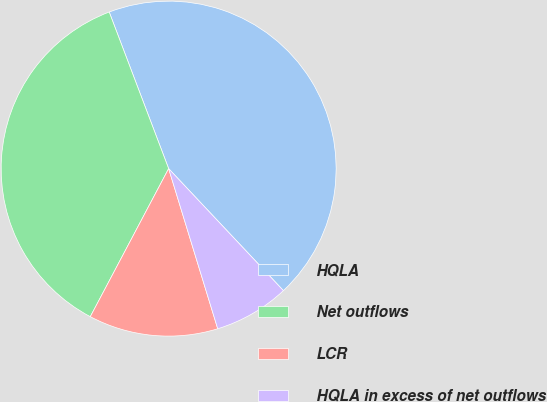<chart> <loc_0><loc_0><loc_500><loc_500><pie_chart><fcel>HQLA<fcel>Net outflows<fcel>LCR<fcel>HQLA in excess of net outflows<nl><fcel>43.76%<fcel>36.48%<fcel>12.48%<fcel>7.28%<nl></chart> 